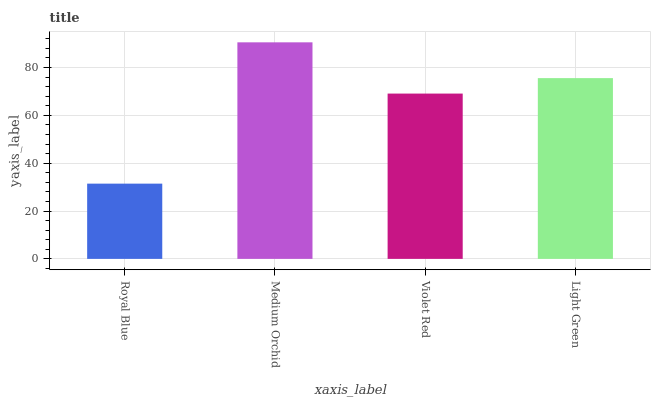Is Royal Blue the minimum?
Answer yes or no. Yes. Is Medium Orchid the maximum?
Answer yes or no. Yes. Is Violet Red the minimum?
Answer yes or no. No. Is Violet Red the maximum?
Answer yes or no. No. Is Medium Orchid greater than Violet Red?
Answer yes or no. Yes. Is Violet Red less than Medium Orchid?
Answer yes or no. Yes. Is Violet Red greater than Medium Orchid?
Answer yes or no. No. Is Medium Orchid less than Violet Red?
Answer yes or no. No. Is Light Green the high median?
Answer yes or no. Yes. Is Violet Red the low median?
Answer yes or no. Yes. Is Medium Orchid the high median?
Answer yes or no. No. Is Medium Orchid the low median?
Answer yes or no. No. 